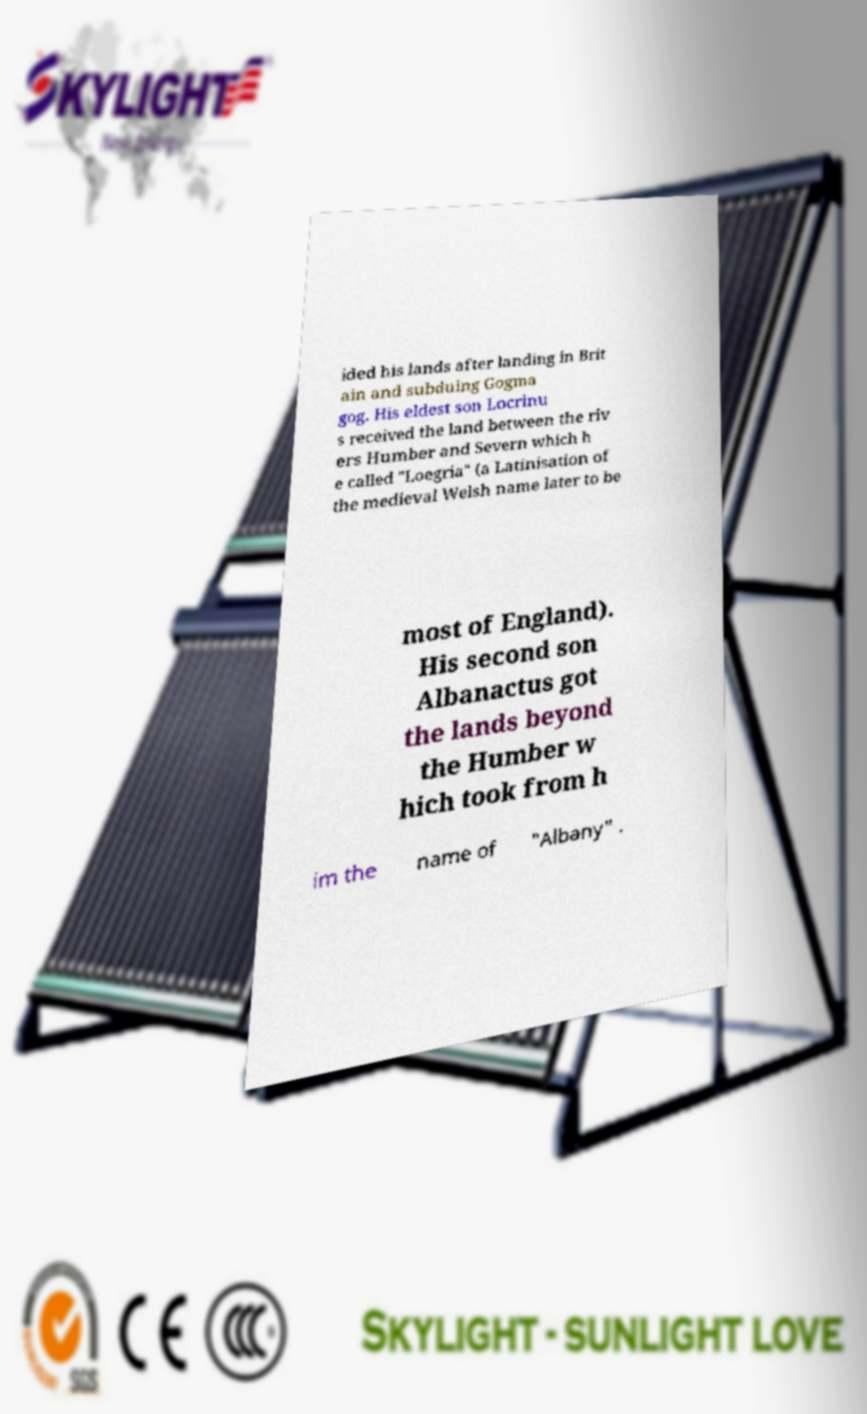Could you assist in decoding the text presented in this image and type it out clearly? ided his lands after landing in Brit ain and subduing Gogma gog. His eldest son Locrinu s received the land between the riv ers Humber and Severn which h e called "Loegria" (a Latinisation of the medieval Welsh name later to be most of England). His second son Albanactus got the lands beyond the Humber w hich took from h im the name of "Albany" . 